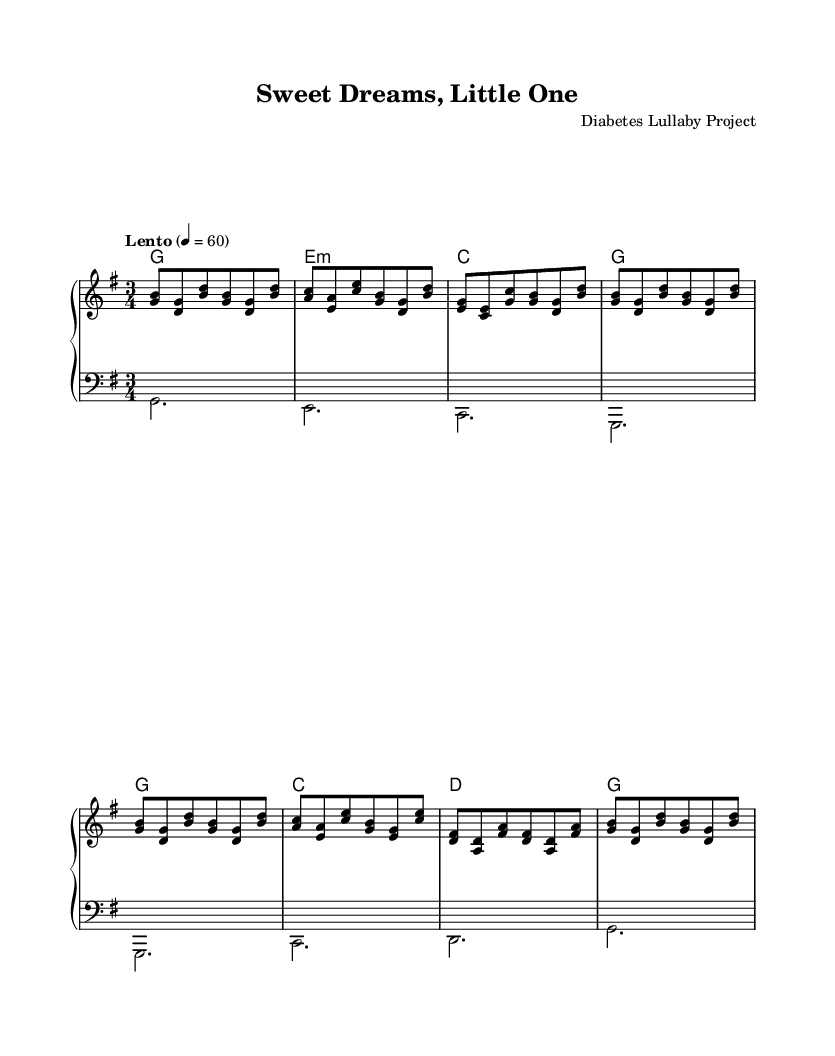What is the key signature of this music? The key signature is G major, which has one sharp (F#) noted in the left part of the music sheet.
Answer: G major What is the time signature of the piece? The time signature is 3/4, indicated at the beginning of the score, meaning there are three beats in each measure and the quarter note gets one beat.
Answer: 3/4 What is the tempo marking of this music? The tempo marking is "Lento", which indicates a slow pace, and is set to a quarter note value of 60 beats per minute.
Answer: Lento How many measures are there in the piece? By counting the measures within the given notation, we see there are 16 measures in total, organized by the repeating phrases.
Answer: 16 What type of musical piece is "Sweet Dreams, Little One"? The music is a lullaby, which is meant to soothe and relax, as indicated by the gentle melodic lines and calm tempo.
Answer: Lullaby Which voices are present in the score? The score features two voices: the upper voice (treble clef) and the lower voice (bass clef), creating a harmonious texture.
Answer: Upper and Lower 